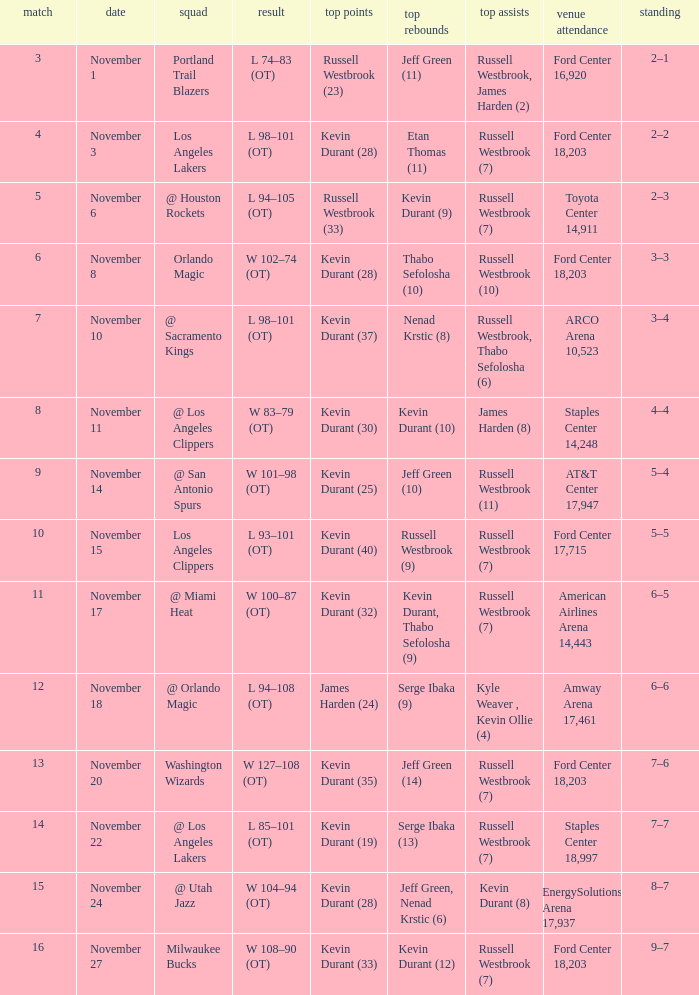When was the game number 3 played? November 1. 